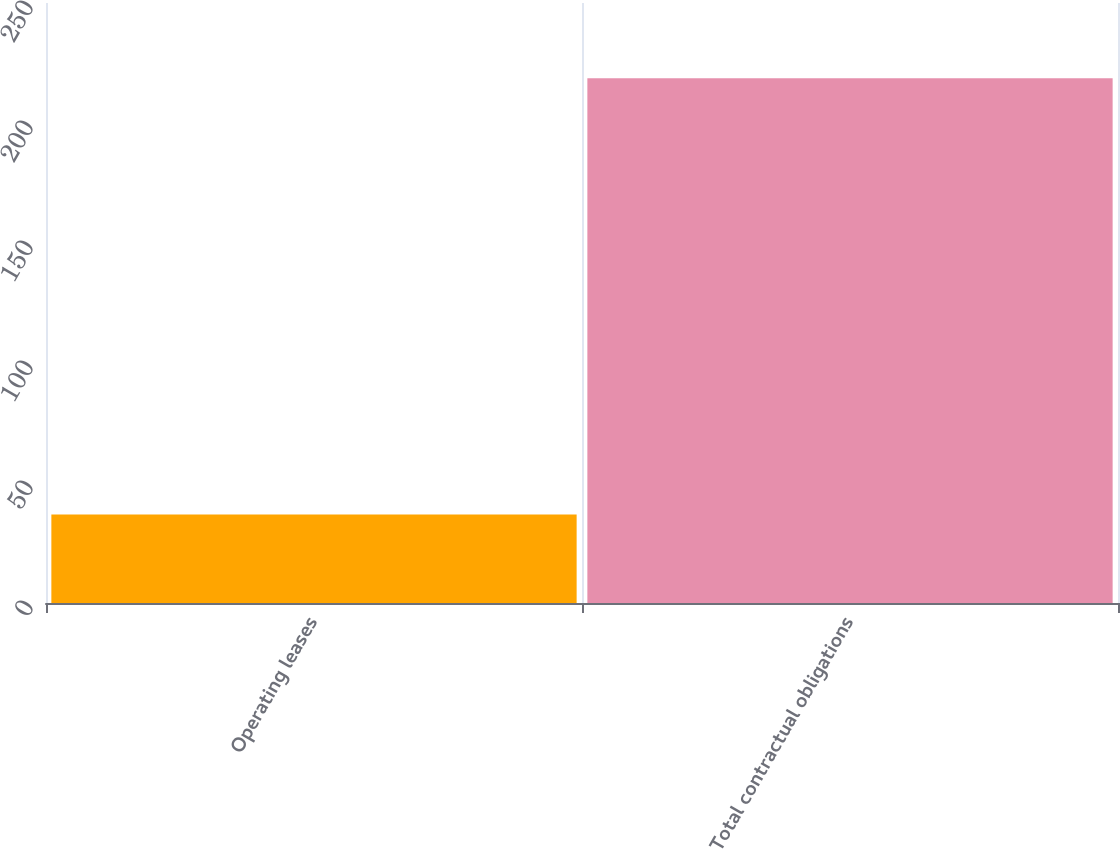Convert chart. <chart><loc_0><loc_0><loc_500><loc_500><bar_chart><fcel>Operating leases<fcel>Total contractual obligations<nl><fcel>36.9<fcel>218.6<nl></chart> 